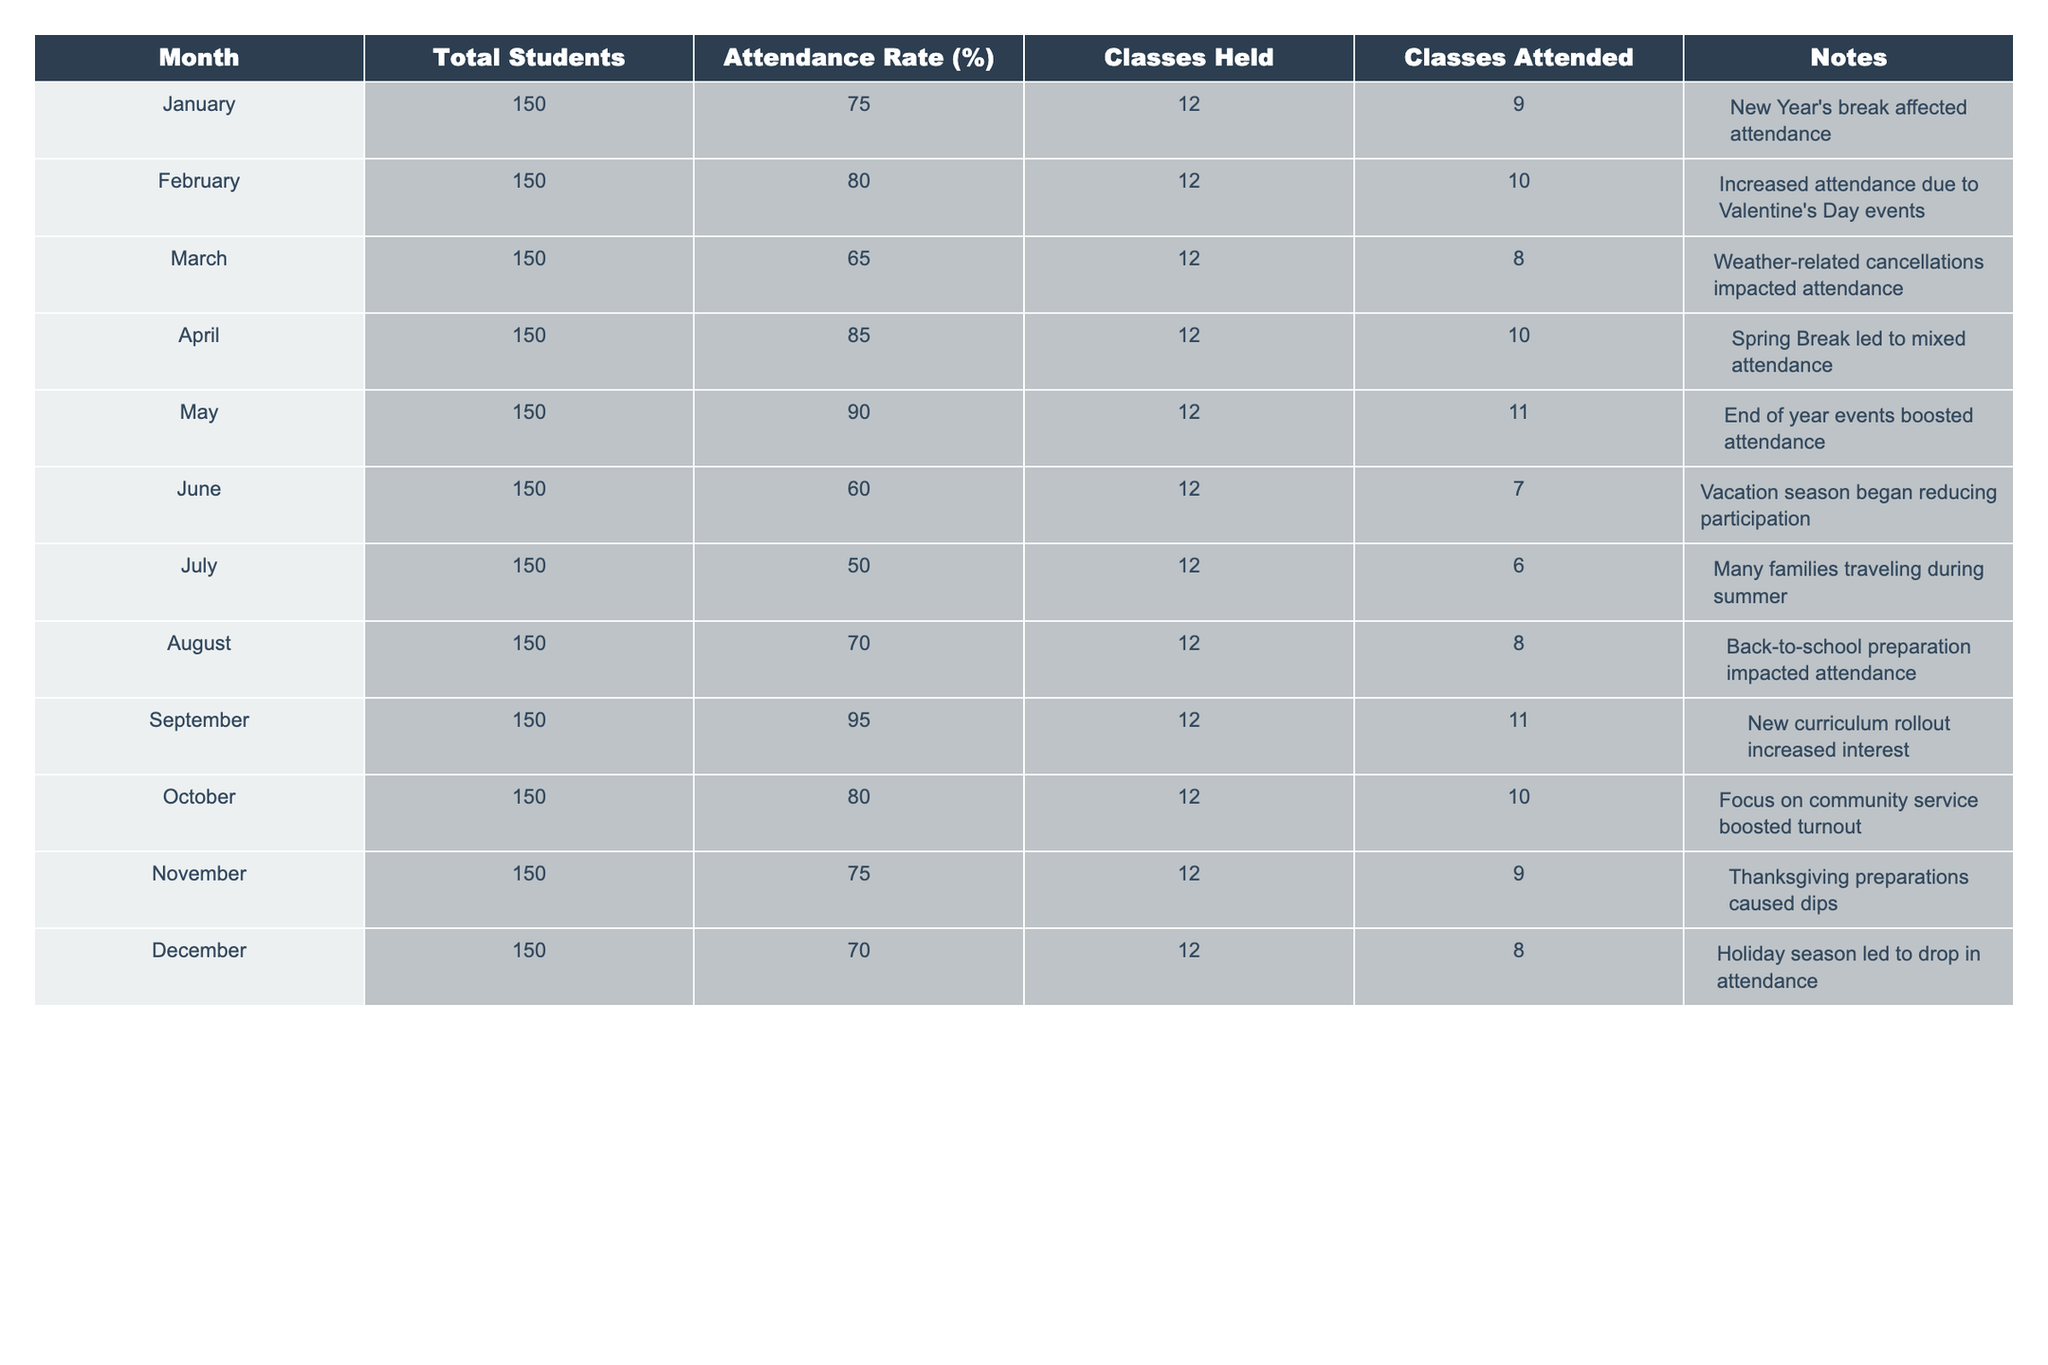What was the highest attendance rate recorded? The table lists monthly attendance rates, and scanning it shows that April has the highest attendance rate at 85%.
Answer: 85% Which month had the lowest attendance rate? Looking through the attendance rates, July has the lowest attendance rate at 50%.
Answer: 50% What was the total number of classes held throughout the year? Each month had 12 classes held, and there are 12 months in a year. Thus, the total number of classes held is 12 x 12 = 144.
Answer: 144 What month had an attendance rate of 90%? Referring to the table, May is the month where the attendance rate is 90%.
Answer: May Was the attendance rate higher in February compared to March? By comparing the two months, February has an 80% attendance rate, while March has a 65% attendance rate. Therefore, February's rate is higher.
Answer: Yes What percentage increase in attendance rate was observed from March to April? March had an attendance rate of 65%, and April had 85%. The increase is 85 - 65 = 20%. To find the percentage increase, divide 20 by the original value (65) and multiply by 100, resulting in (20/65)*100 ≈ 30.77%.
Answer: 30.77% Which month showed a significant drop in attendance due to vacations? Both June and July experienced drops due to the vacation season, with June at 60% and July at 50%. While July had the highest drop, June also experienced a notable decline.
Answer: July On average, what was the attendance rate for the last quarter of the year (October, November, December)? Adding the attendance rates for these three months gives 80% (October) + 75% (November) + 70% (December) = 225%. Dividing by 3 for the average results in 225% / 3 = 75%.
Answer: 75% During which month was the attendance affected by a New Year's break, and what was the rate? January recorded a 75% attendance rate, which was noted to be affected by the New Year's break.
Answer: January, 75% Did the attendance improve in September compared to August? In September, the attendance rate was 95%, while in August, it was 70%. Thus, the attendance improved significantly in September.
Answer: Yes What pattern in attendance can be observed during the summer months (June, July, August)? The attendance rates for June (60%), July (50%), and August (70%) reveal a decreasing trend initially, followed by a slight increase in August.
Answer: Decreasing trend, slight increase in August 